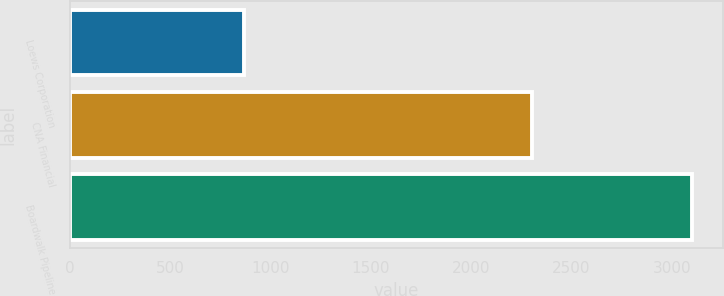Convert chart to OTSL. <chart><loc_0><loc_0><loc_500><loc_500><bar_chart><fcel>Loews Corporation<fcel>CNA Financial<fcel>Boardwalk Pipeline<nl><fcel>867<fcel>2303<fcel>3100<nl></chart> 